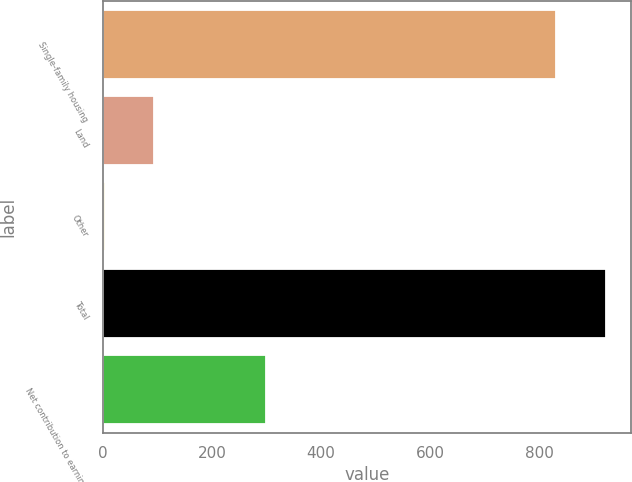<chart> <loc_0><loc_0><loc_500><loc_500><bar_chart><fcel>Single-family housing<fcel>Land<fcel>Other<fcel>Total<fcel>Net contribution to earnings<nl><fcel>832<fcel>94<fcel>4<fcel>922<fcel>299<nl></chart> 